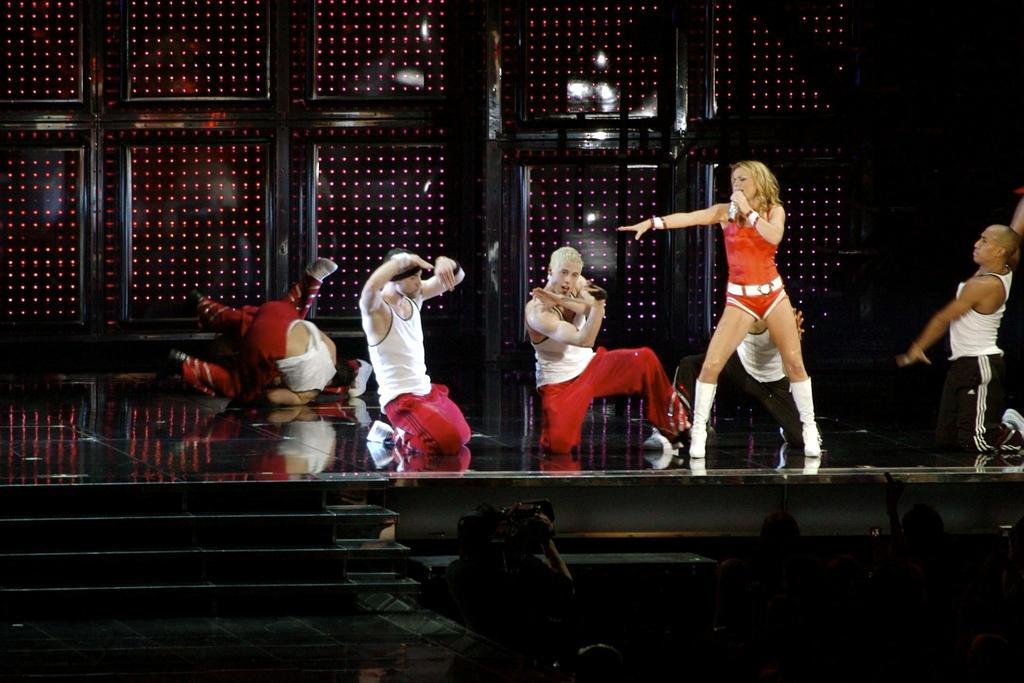What is happening on the stage in the image? There are people on the stage in the image. Can you describe the appearance of the people on the stage? The people on the stage are wearing different color dresses. What is one person on the stage holding? One person on the stage is holding a microphone. What architectural feature can be seen in the image? There are stairs visible in the image. What color is the background of the image? The background of the image is black. Can you tell me how many flowers are on the stage in the image? There are no flowers visible on the stage in the image. What type of tank is present in the image? There is no tank present in the image. 